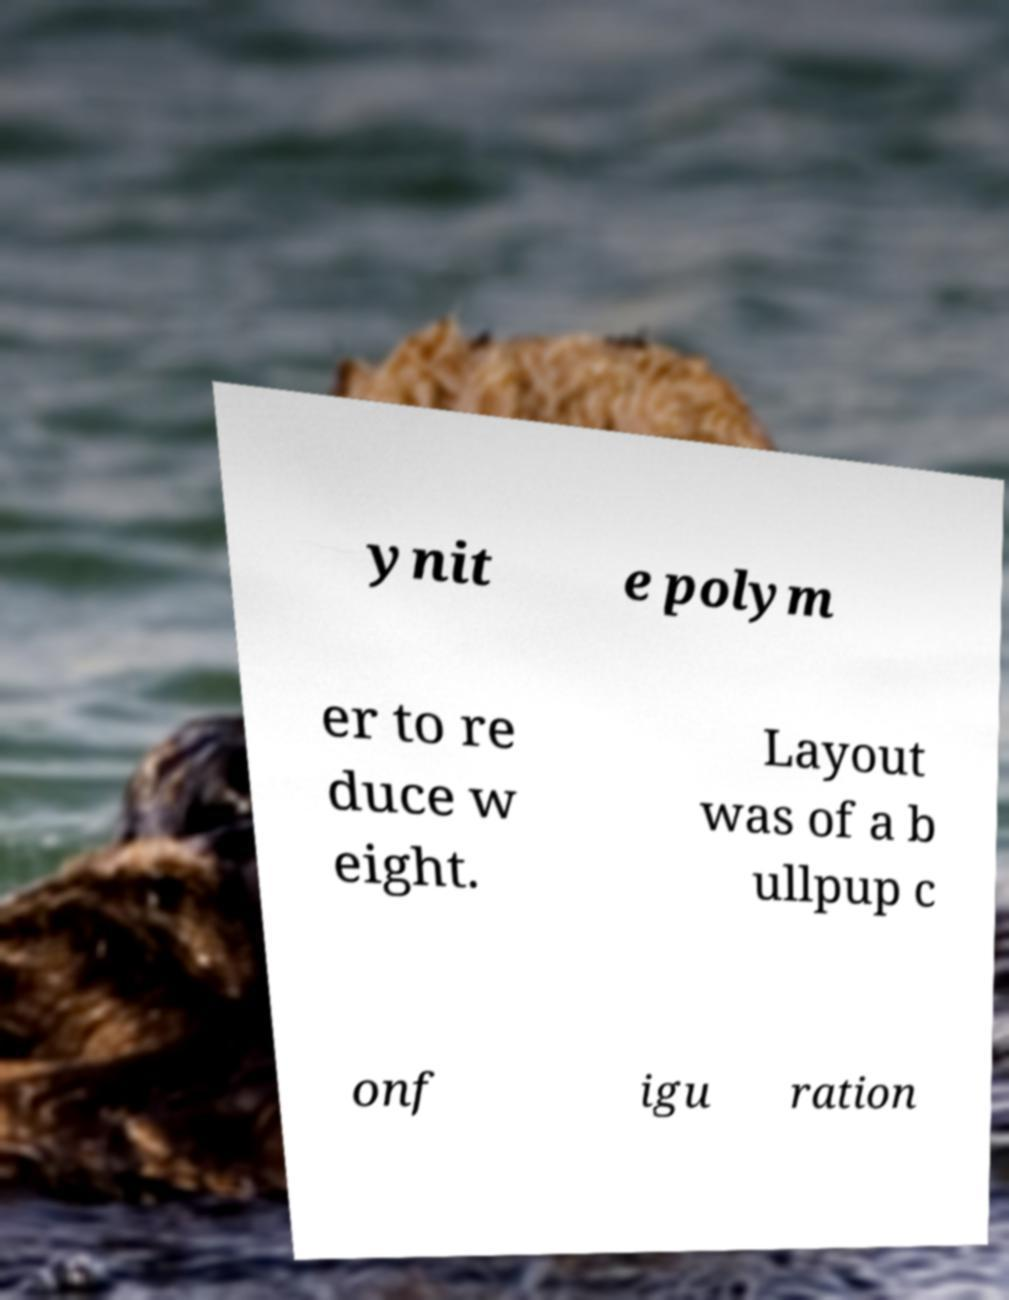Can you accurately transcribe the text from the provided image for me? ynit e polym er to re duce w eight. Layout was of a b ullpup c onf igu ration 